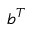Convert formula to latex. <formula><loc_0><loc_0><loc_500><loc_500>b ^ { T }</formula> 